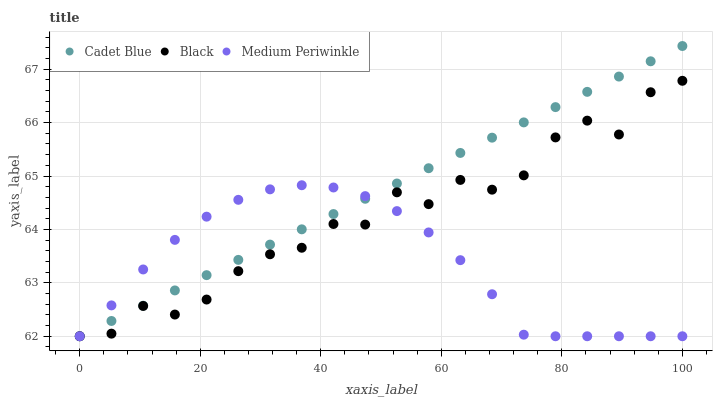Does Medium Periwinkle have the minimum area under the curve?
Answer yes or no. Yes. Does Cadet Blue have the maximum area under the curve?
Answer yes or no. Yes. Does Black have the minimum area under the curve?
Answer yes or no. No. Does Black have the maximum area under the curve?
Answer yes or no. No. Is Cadet Blue the smoothest?
Answer yes or no. Yes. Is Black the roughest?
Answer yes or no. Yes. Is Black the smoothest?
Answer yes or no. No. Is Cadet Blue the roughest?
Answer yes or no. No. Does Medium Periwinkle have the lowest value?
Answer yes or no. Yes. Does Cadet Blue have the highest value?
Answer yes or no. Yes. Does Black have the highest value?
Answer yes or no. No. Does Cadet Blue intersect Medium Periwinkle?
Answer yes or no. Yes. Is Cadet Blue less than Medium Periwinkle?
Answer yes or no. No. Is Cadet Blue greater than Medium Periwinkle?
Answer yes or no. No. 